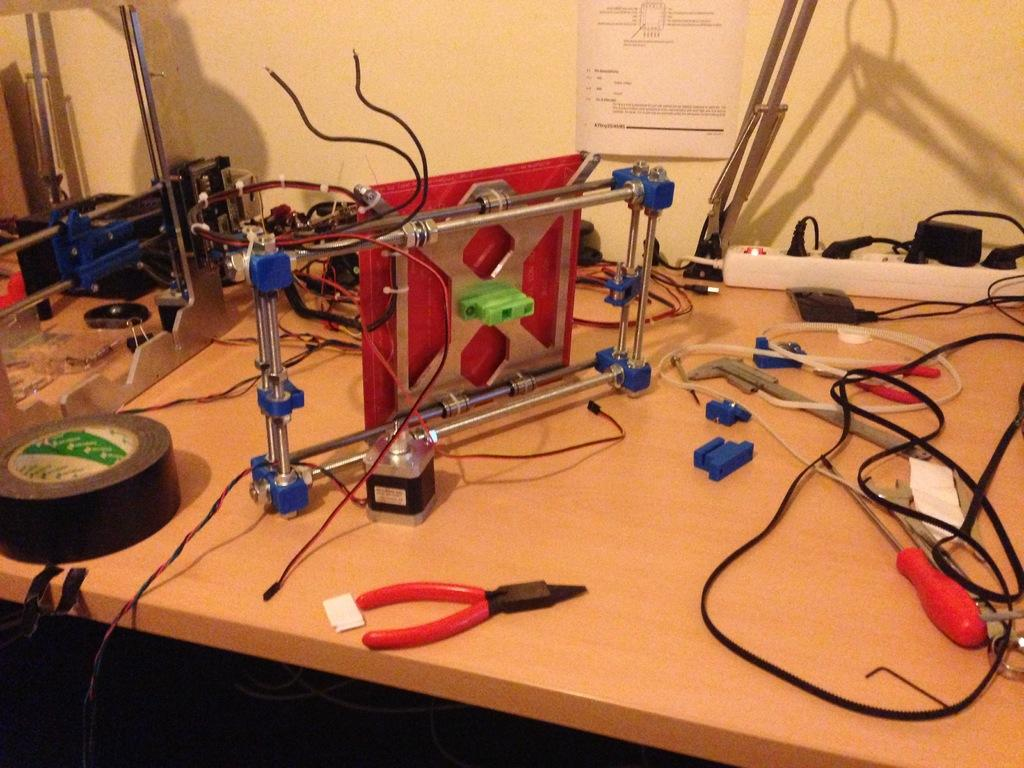What can be seen on the table in the image? There are many tools and objects on the table. Can you describe a specific item on the table? There is an extension box on the table. How many devices are connected to the extension box? There are multiple plugs plugged into the extension box. What is visible on the wall in the image? There is a poster on the wall in the image. What type of wood is the ship made of in the image? There is no ship present in the image, so it is not possible to determine the type of wood used in its construction. 